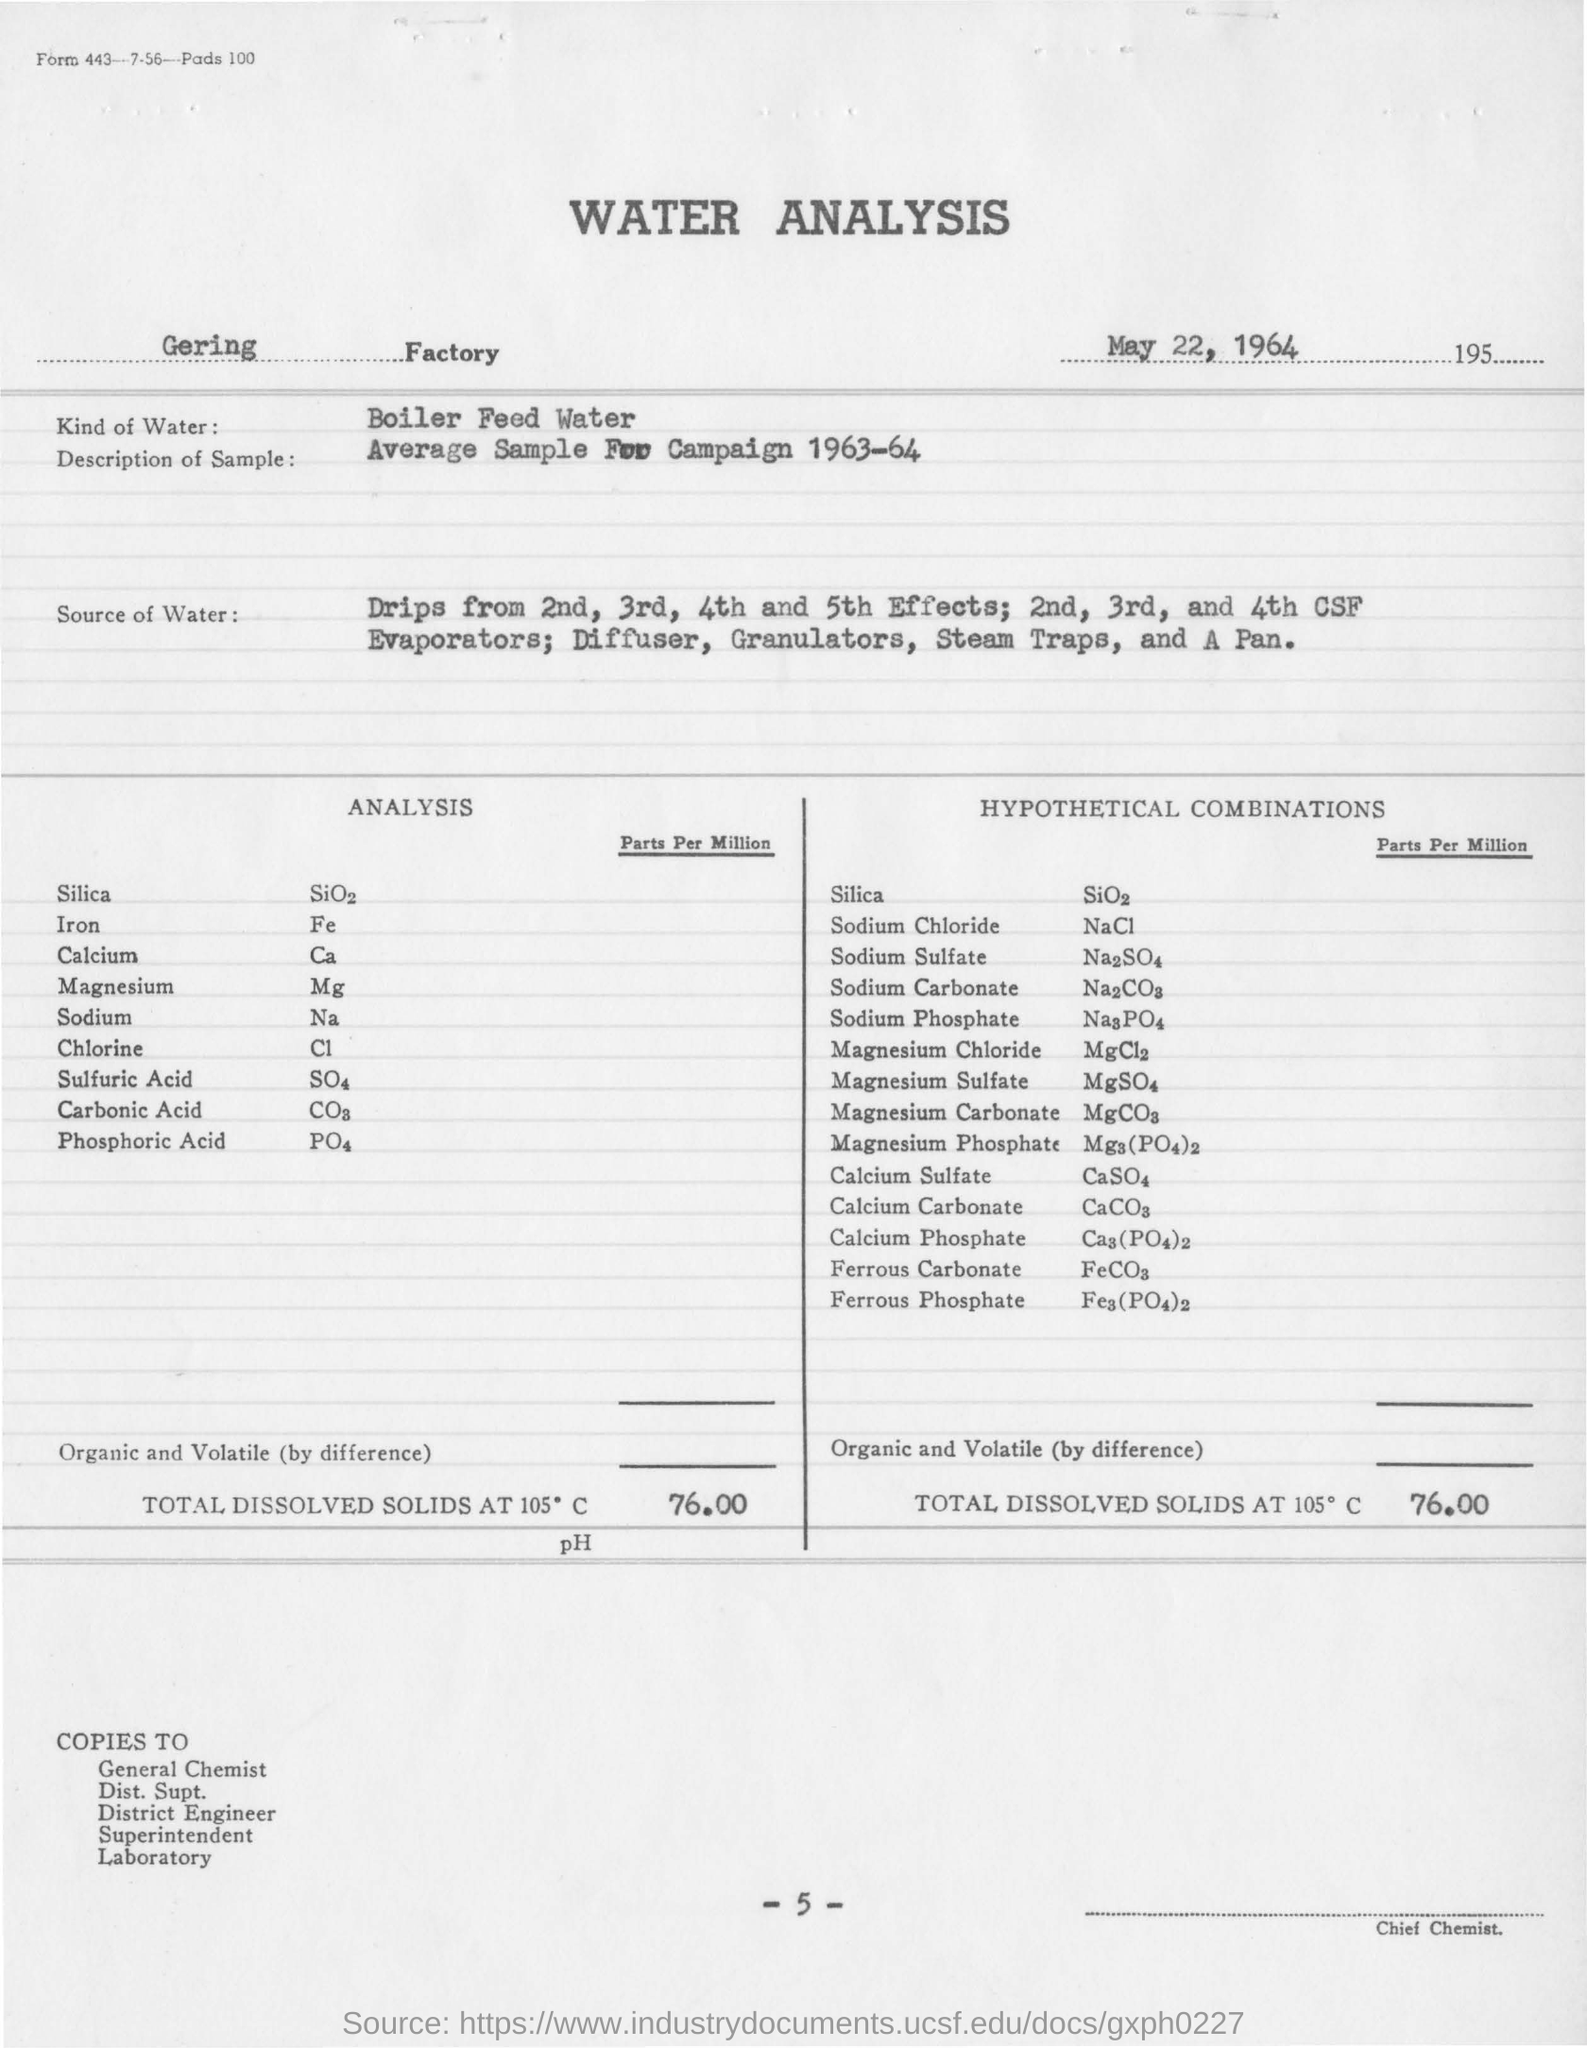what is the kind of water used in analysis ?
 Boiler Feed Water 